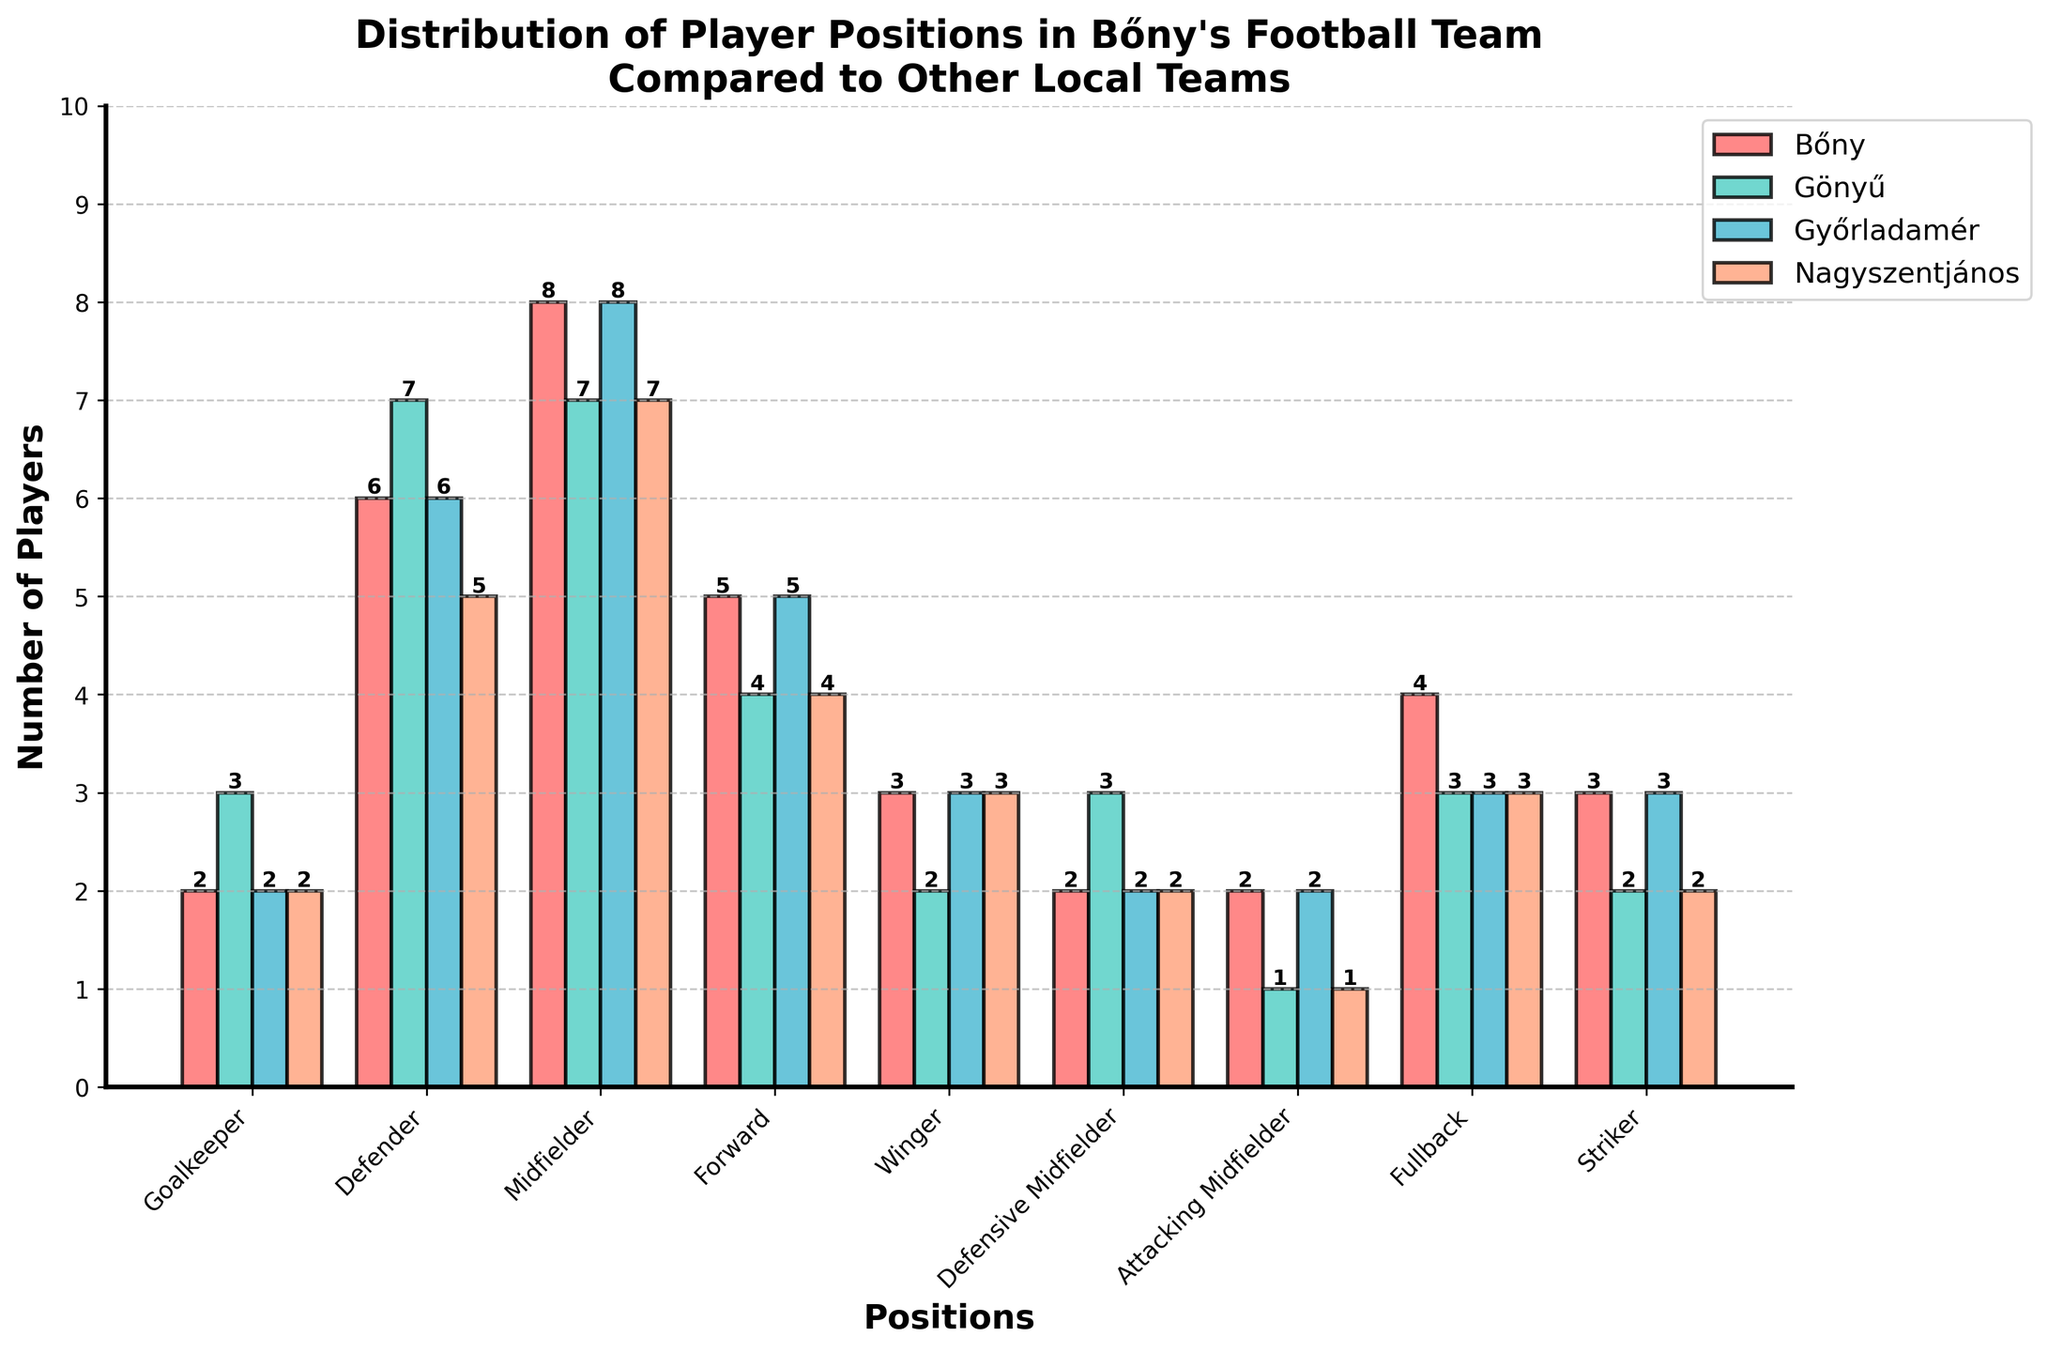What's the total number of midfielders across all teams? To find the total number of midfielders, sum the number of midfielders in each team: Bőny (8) + Gönyű (7) + Győrladamér (8) + Nagyszentjános (7). The total is 8 + 7 + 8 + 7 = 30.
Answer: 30 Which team has the highest number of defenders? Compare the number of defenders in each team: Bőny (6), Gönyű (7), Győrladamér (6), Nagyszentjános (5). Gönyű has the highest number of defenders.
Answer: Gönyű How many more forwards does Bőny have compared to Nagyszentjános? Bőny has 5 forwards and Nagyszentjános has 4 forwards. The difference is 5 - 4 = 1.
Answer: 1 Which position do all teams have the same number of players? Observe the bar heights for all teams across positions. The "Goalkeeper" and "Defensive Midfielder" positions have 2 players in all teams.
Answer: Goalkeeper, Defensive Midfielder Which position has the highest total number of players when all teams are combined? Sum the number of players for each position across all teams and compare. The Midfielder position has the highest total: 8+7+8+7 = 30.
Answer: Midfielder What's the total number of players in Bőny's team across all positions? Sum the number of players for each position in Bőny: 2+6+8+5+3+2+2+4+3 = 35.
Answer: 35 Is the number of attacking midfielders in Bőny greater than or equal to the number in Győrladamér? Bőny and Győrladamér both have 2 attacking midfielders, so Bőny's count is equal to Győrladamér's.
Answer: Equal How does the number of fullbacks in Bőny compare to the number of fullbacks in Gönyű? Bőny has 4 fullbacks, while Gönyű has 3 fullbacks. Bőny has 1 more fullback than Gönyű.
Answer: Bőny has 1 more Which team has the fewest wingers? Compare the number of wingers in each team: Bőny (3), Gönyű (2), Győrladamér (3), Nagyszentjános (3). Gönyű has the fewest wingers.
Answer: Gönyű 